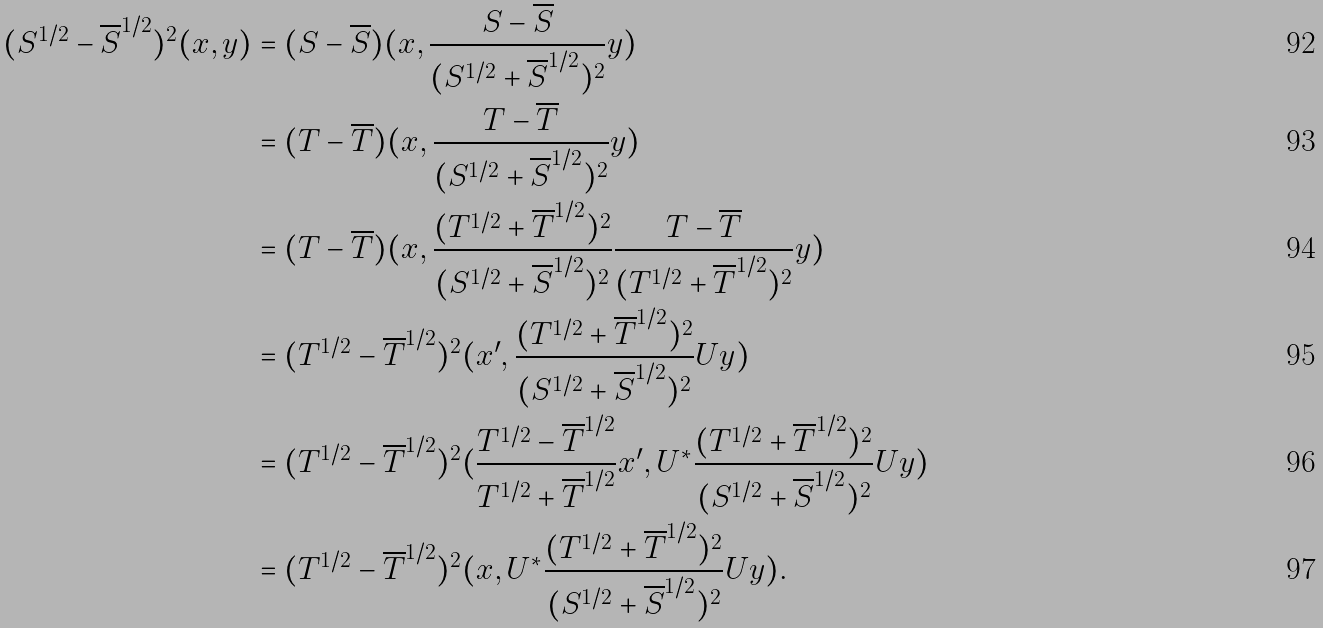Convert formula to latex. <formula><loc_0><loc_0><loc_500><loc_500>( S ^ { 1 / 2 } - { \overline { S } } ^ { 1 / 2 } ) ^ { 2 } ( x , y ) & = ( S - \overline { S } ) ( x , \frac { S - \overline { S } } { ( S ^ { 1 / 2 } + { \overline { S } } ^ { 1 / 2 } ) ^ { 2 } } y ) \\ & = ( T - \overline { T } ) ( x , \frac { T - \overline { T } } { ( S ^ { 1 / 2 } + { \overline { S } } ^ { 1 / 2 } ) ^ { 2 } } y ) \\ & = ( T - \overline { T } ) ( x , \frac { ( T ^ { 1 / 2 } + { \overline { T } } ^ { 1 / 2 } ) ^ { 2 } } { ( S ^ { 1 / 2 } + { \overline { S } } ^ { 1 / 2 } ) ^ { 2 } } \frac { T - \overline { T } } { ( T ^ { 1 / 2 } + { \overline { T } } ^ { 1 / 2 } ) ^ { 2 } } y ) \\ & = ( T ^ { 1 / 2 } - { \overline { T } } ^ { 1 / 2 } ) ^ { 2 } ( x ^ { \prime } , \frac { ( T ^ { 1 / 2 } + { \overline { T } } ^ { 1 / 2 } ) ^ { 2 } } { ( S ^ { 1 / 2 } + { \overline { S } } ^ { 1 / 2 } ) ^ { 2 } } U y ) \\ & = ( T ^ { 1 / 2 } - { \overline { T } } ^ { 1 / 2 } ) ^ { 2 } ( \frac { T ^ { 1 / 2 } - { \overline { T } } ^ { 1 / 2 } } { T ^ { 1 / 2 } + { \overline { T } } ^ { 1 / 2 } } x ^ { \prime } , U ^ { * } \frac { ( T ^ { 1 / 2 } + { \overline { T } } ^ { 1 / 2 } ) ^ { 2 } } { ( S ^ { 1 / 2 } + { \overline { S } } ^ { 1 / 2 } ) ^ { 2 } } U y ) \\ & = ( T ^ { 1 / 2 } - { \overline { T } } ^ { 1 / 2 } ) ^ { 2 } ( x , U ^ { * } \frac { ( T ^ { 1 / 2 } + { \overline { T } } ^ { 1 / 2 } ) ^ { 2 } } { ( S ^ { 1 / 2 } + { \overline { S } } ^ { 1 / 2 } ) ^ { 2 } } U y ) .</formula> 